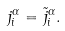<formula> <loc_0><loc_0><loc_500><loc_500>j _ { i } ^ { \alpha } = \tilde { j } _ { i } ^ { \alpha } .</formula> 